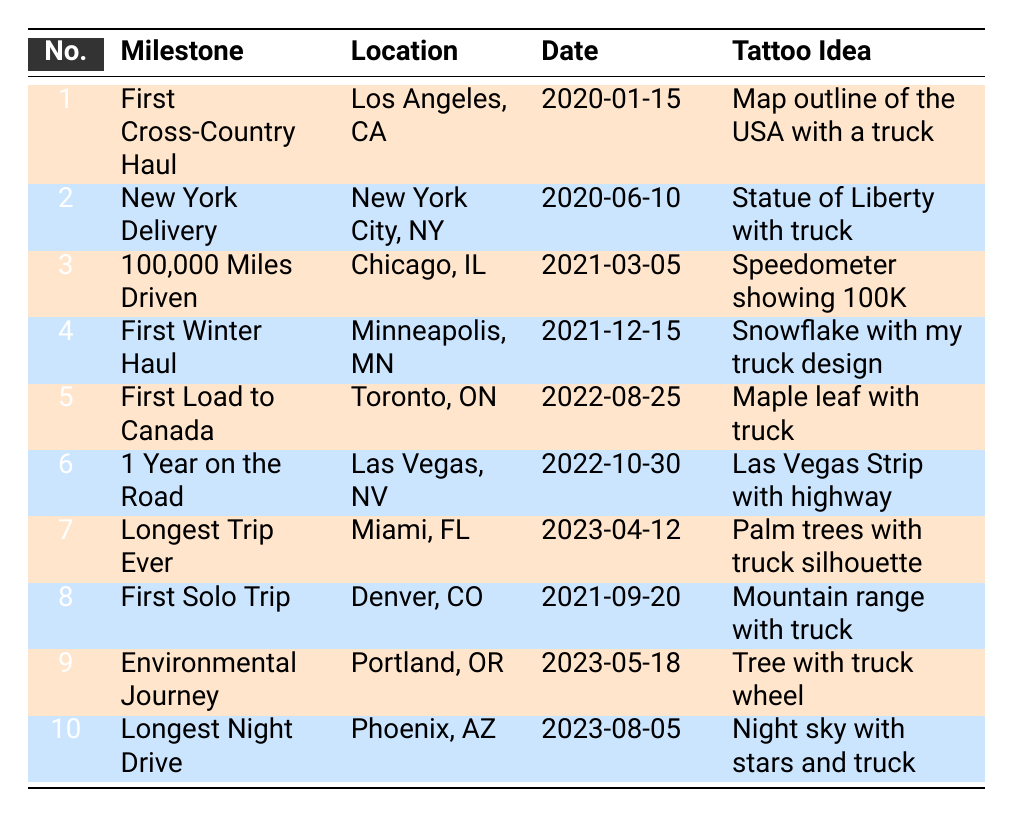What is the milestone celebrated in Miami, FL? The table shows that the milestone celebrated in Miami, FL is "Longest Trip Ever", which happened on April 12, 2023.
Answer: Longest Trip Ever What date did I commemorate my first load to Canada? Looking at the table, the first load to Canada is listed as occurring on August 25, 2022.
Answer: 2022-08-25 How many milestones were celebrated in 2023? By checking the dates in the table, there are three milestones that occurred in 2023: "Longest Trip Ever", "Environmental Journey", and "Longest Night Drive", totaling three milestones.
Answer: 3 Is there a tattoo idea that features a snowflake? Yes, the table indicates that there is a tattoo idea featuring a snowflake, associated with the milestone "First Winter Haul" in Minneapolis, MN.
Answer: Yes What is the location for the milestone associated with the 100,000 miles driven? The location associated with the "100,000 Miles Driven" milestone is Chicago, IL, as stated in the table.
Answer: Chicago, IL What tattoo ideas commemorate milestones related to winter and environmental themes? The two tattoo ideas related to winter and environmental themes are: "First Winter Haul" with a tattoo idea of "Snowflake with my truck design" and "Environmental Journey" with a tattoo idea of "Tree with truck wheel".
Answer: Snowflake with my truck design; Tree with truck wheel Which milestone is related to a year on the road? The milestone related to one year on the road is "1 Year on the Road," which took place in Las Vegas, NV on October 30, 2022.
Answer: 1 Year on the Road How many tattoos celebrate locations in the eastern United States? Analyzing the table, the milestones located in the eastern United States are "New York Delivery" in New York City, NY and "Longest Trip Ever" in Miami, FL. Thus, there are two tattoos celebrating locations in the eastern US.
Answer: 2 What is the common theme of the tattoo for the longest night drive? The tattoo idea for the "Longest Night Drive", which happened on August 5, 2023, is themed around a night sky with stars and a truck.
Answer: Night sky with stars and truck 